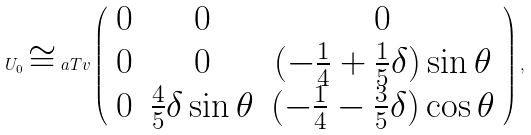Convert formula to latex. <formula><loc_0><loc_0><loc_500><loc_500>U _ { 0 } \cong a T v \left ( \begin{array} { c c c } 0 & 0 & 0 \\ 0 & 0 & ( - \frac { 1 } { 4 } + \frac { 1 } { 5 } \delta ) \sin \theta \\ 0 & \frac { 4 } { 5 } \delta \sin \theta & ( - \frac { 1 } { 4 } - \frac { 3 } { 5 } \delta ) \cos \theta \end{array} \right ) ,</formula> 